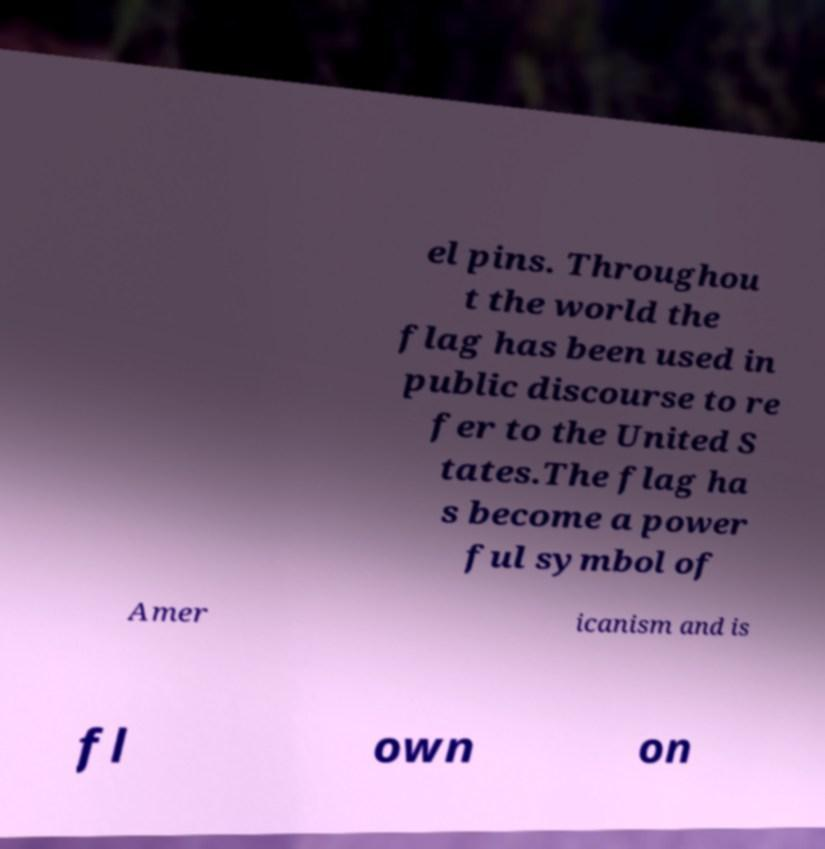For documentation purposes, I need the text within this image transcribed. Could you provide that? el pins. Throughou t the world the flag has been used in public discourse to re fer to the United S tates.The flag ha s become a power ful symbol of Amer icanism and is fl own on 